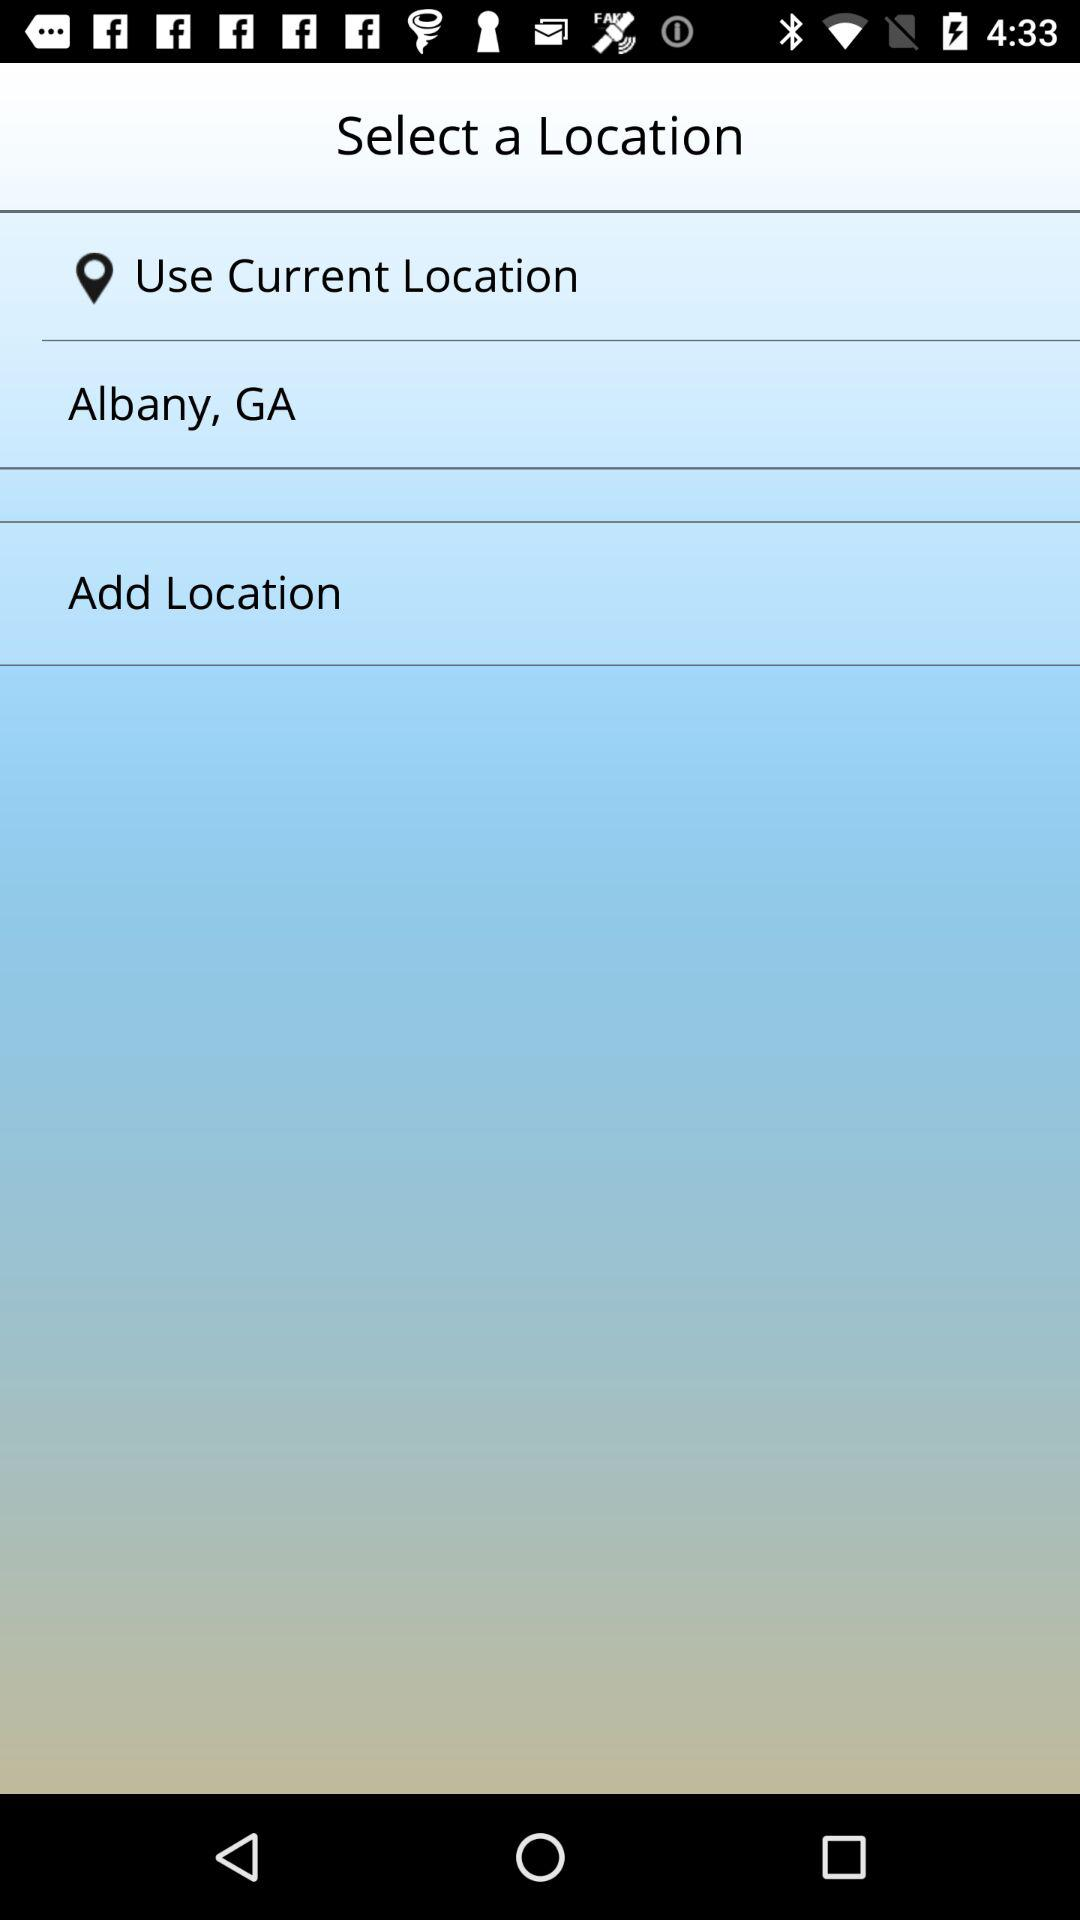What is the mentioned location? The mentioned location is Albany, GA. 